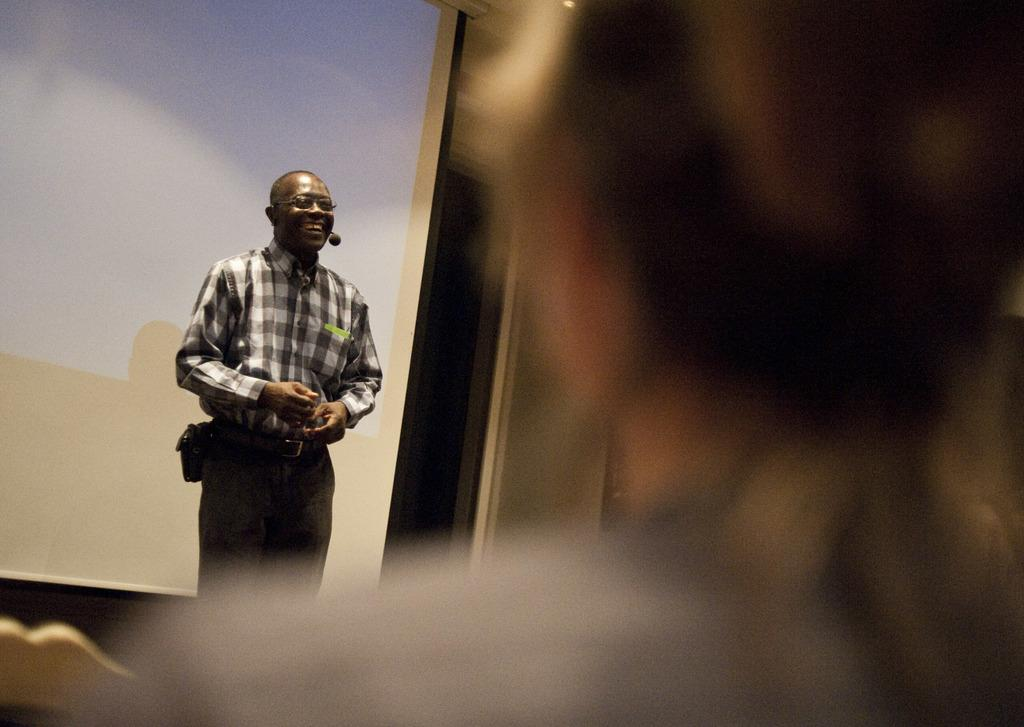What is the position of the man in the image? The man is standing on the floor in the image. What is the man doing in the image? The man is explaining something in the image. What is behind the man in the image? There is a projector screen behind the man in the image. Who is present in front of the man in the image? There is another person in front of the man in the image. How does the man increase his swimming speed in the image? There is no swimming or increase in speed mentioned in the image; the man is standing and explaining something. 